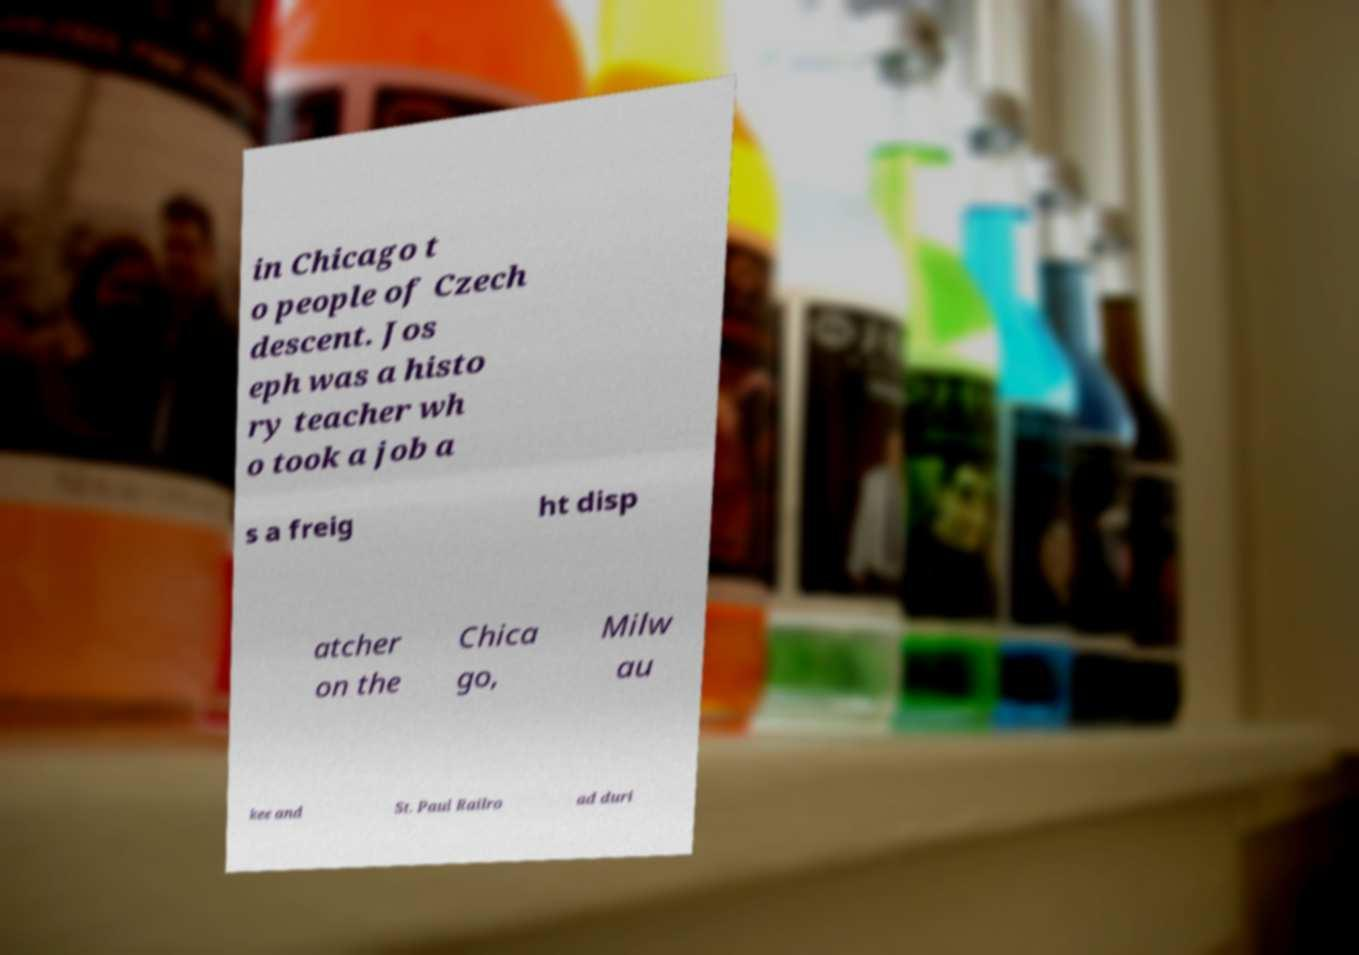What messages or text are displayed in this image? I need them in a readable, typed format. in Chicago t o people of Czech descent. Jos eph was a histo ry teacher wh o took a job a s a freig ht disp atcher on the Chica go, Milw au kee and St. Paul Railro ad duri 